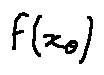Convert formula to latex. <formula><loc_0><loc_0><loc_500><loc_500>f ( x _ { \theta } )</formula> 